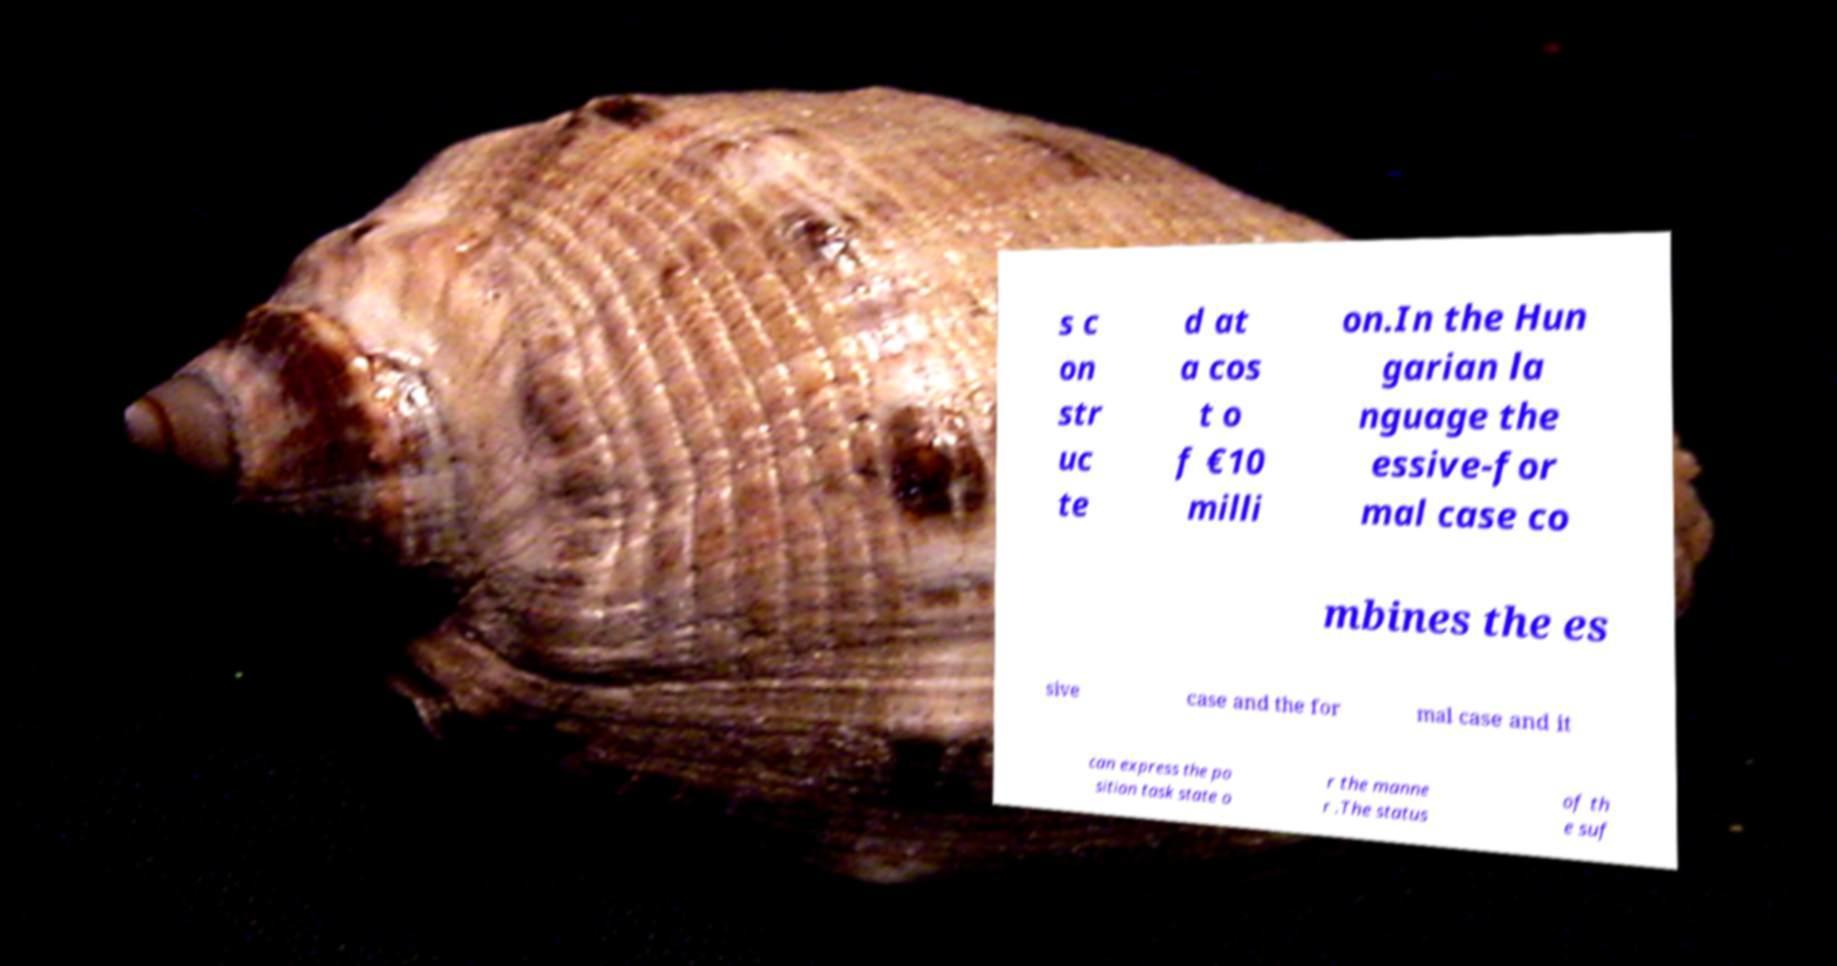Please identify and transcribe the text found in this image. s c on str uc te d at a cos t o f €10 milli on.In the Hun garian la nguage the essive-for mal case co mbines the es sive case and the for mal case and it can express the po sition task state o r the manne r .The status of th e suf 